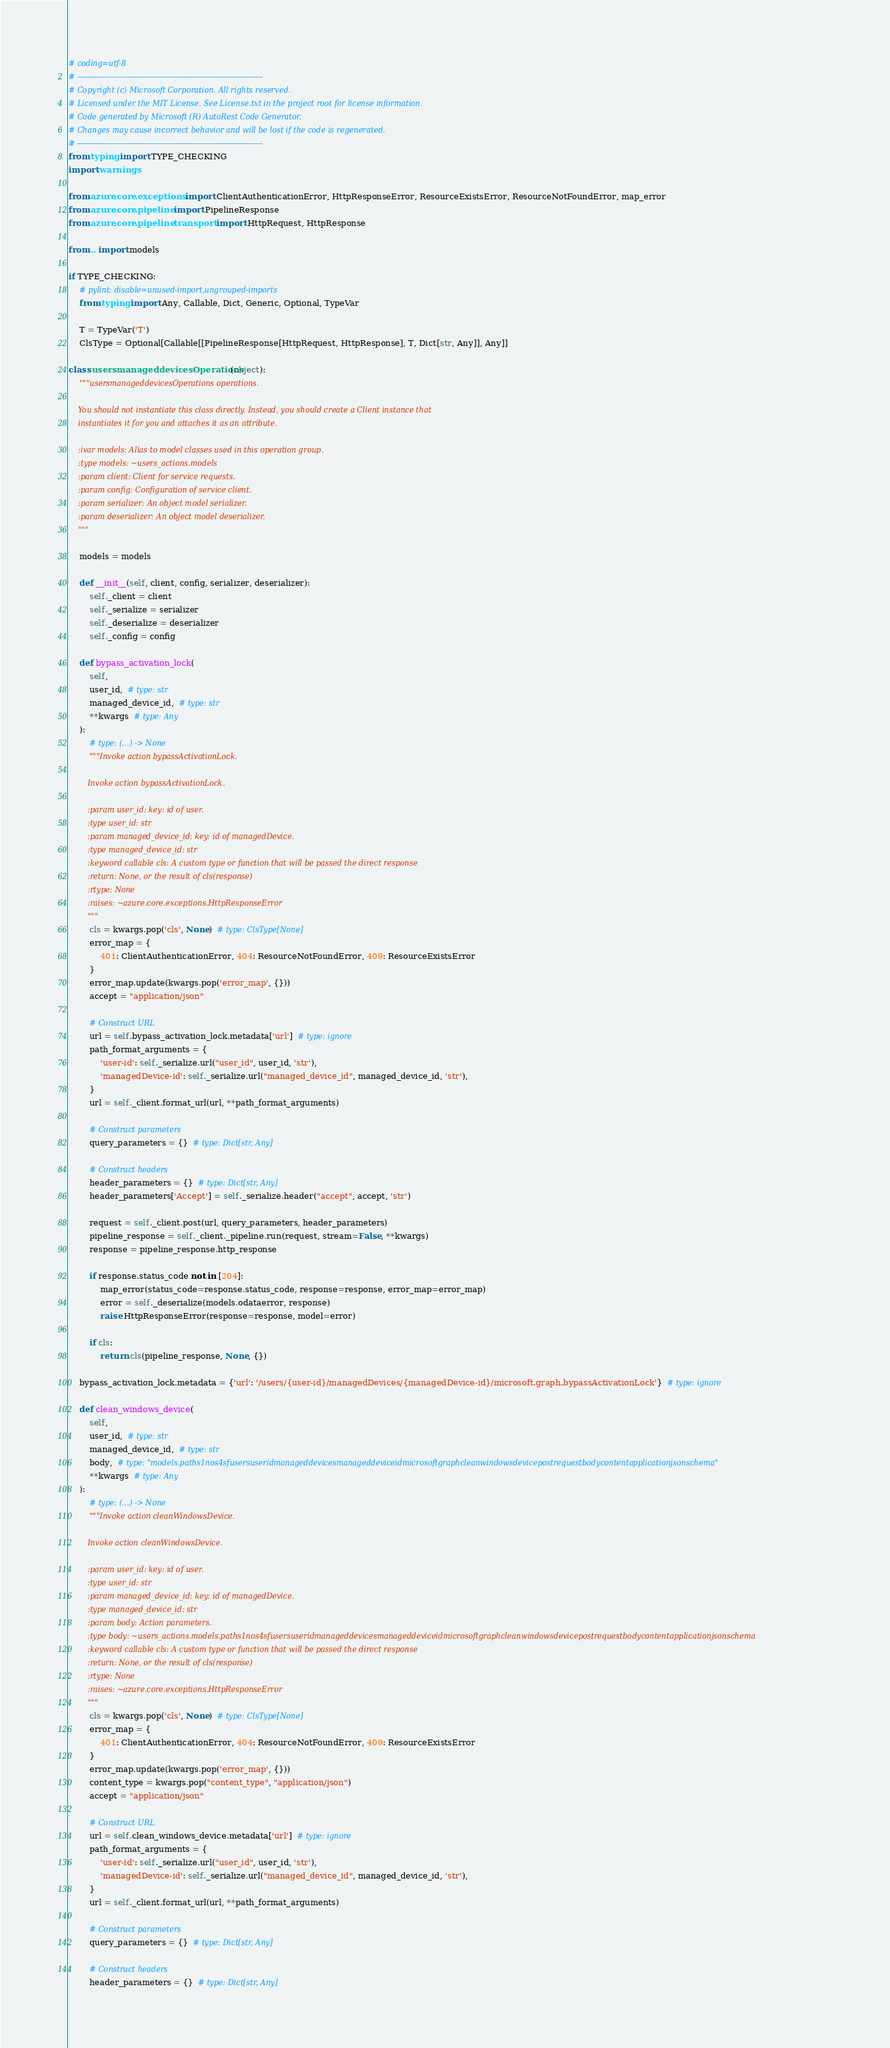Convert code to text. <code><loc_0><loc_0><loc_500><loc_500><_Python_># coding=utf-8
# --------------------------------------------------------------------------
# Copyright (c) Microsoft Corporation. All rights reserved.
# Licensed under the MIT License. See License.txt in the project root for license information.
# Code generated by Microsoft (R) AutoRest Code Generator.
# Changes may cause incorrect behavior and will be lost if the code is regenerated.
# --------------------------------------------------------------------------
from typing import TYPE_CHECKING
import warnings

from azure.core.exceptions import ClientAuthenticationError, HttpResponseError, ResourceExistsError, ResourceNotFoundError, map_error
from azure.core.pipeline import PipelineResponse
from azure.core.pipeline.transport import HttpRequest, HttpResponse

from .. import models

if TYPE_CHECKING:
    # pylint: disable=unused-import,ungrouped-imports
    from typing import Any, Callable, Dict, Generic, Optional, TypeVar

    T = TypeVar('T')
    ClsType = Optional[Callable[[PipelineResponse[HttpRequest, HttpResponse], T, Dict[str, Any]], Any]]

class usersmanageddevicesOperations(object):
    """usersmanageddevicesOperations operations.

    You should not instantiate this class directly. Instead, you should create a Client instance that
    instantiates it for you and attaches it as an attribute.

    :ivar models: Alias to model classes used in this operation group.
    :type models: ~users_actions.models
    :param client: Client for service requests.
    :param config: Configuration of service client.
    :param serializer: An object model serializer.
    :param deserializer: An object model deserializer.
    """

    models = models

    def __init__(self, client, config, serializer, deserializer):
        self._client = client
        self._serialize = serializer
        self._deserialize = deserializer
        self._config = config

    def bypass_activation_lock(
        self,
        user_id,  # type: str
        managed_device_id,  # type: str
        **kwargs  # type: Any
    ):
        # type: (...) -> None
        """Invoke action bypassActivationLock.

        Invoke action bypassActivationLock.

        :param user_id: key: id of user.
        :type user_id: str
        :param managed_device_id: key: id of managedDevice.
        :type managed_device_id: str
        :keyword callable cls: A custom type or function that will be passed the direct response
        :return: None, or the result of cls(response)
        :rtype: None
        :raises: ~azure.core.exceptions.HttpResponseError
        """
        cls = kwargs.pop('cls', None)  # type: ClsType[None]
        error_map = {
            401: ClientAuthenticationError, 404: ResourceNotFoundError, 409: ResourceExistsError
        }
        error_map.update(kwargs.pop('error_map', {}))
        accept = "application/json"

        # Construct URL
        url = self.bypass_activation_lock.metadata['url']  # type: ignore
        path_format_arguments = {
            'user-id': self._serialize.url("user_id", user_id, 'str'),
            'managedDevice-id': self._serialize.url("managed_device_id", managed_device_id, 'str'),
        }
        url = self._client.format_url(url, **path_format_arguments)

        # Construct parameters
        query_parameters = {}  # type: Dict[str, Any]

        # Construct headers
        header_parameters = {}  # type: Dict[str, Any]
        header_parameters['Accept'] = self._serialize.header("accept", accept, 'str')

        request = self._client.post(url, query_parameters, header_parameters)
        pipeline_response = self._client._pipeline.run(request, stream=False, **kwargs)
        response = pipeline_response.http_response

        if response.status_code not in [204]:
            map_error(status_code=response.status_code, response=response, error_map=error_map)
            error = self._deserialize(models.odataerror, response)
            raise HttpResponseError(response=response, model=error)

        if cls:
            return cls(pipeline_response, None, {})

    bypass_activation_lock.metadata = {'url': '/users/{user-id}/managedDevices/{managedDevice-id}/microsoft.graph.bypassActivationLock'}  # type: ignore

    def clean_windows_device(
        self,
        user_id,  # type: str
        managed_device_id,  # type: str
        body,  # type: "models.paths1nos4sfusersuseridmanageddevicesmanageddeviceidmicrosoftgraphcleanwindowsdevicepostrequestbodycontentapplicationjsonschema"
        **kwargs  # type: Any
    ):
        # type: (...) -> None
        """Invoke action cleanWindowsDevice.

        Invoke action cleanWindowsDevice.

        :param user_id: key: id of user.
        :type user_id: str
        :param managed_device_id: key: id of managedDevice.
        :type managed_device_id: str
        :param body: Action parameters.
        :type body: ~users_actions.models.paths1nos4sfusersuseridmanageddevicesmanageddeviceidmicrosoftgraphcleanwindowsdevicepostrequestbodycontentapplicationjsonschema
        :keyword callable cls: A custom type or function that will be passed the direct response
        :return: None, or the result of cls(response)
        :rtype: None
        :raises: ~azure.core.exceptions.HttpResponseError
        """
        cls = kwargs.pop('cls', None)  # type: ClsType[None]
        error_map = {
            401: ClientAuthenticationError, 404: ResourceNotFoundError, 409: ResourceExistsError
        }
        error_map.update(kwargs.pop('error_map', {}))
        content_type = kwargs.pop("content_type", "application/json")
        accept = "application/json"

        # Construct URL
        url = self.clean_windows_device.metadata['url']  # type: ignore
        path_format_arguments = {
            'user-id': self._serialize.url("user_id", user_id, 'str'),
            'managedDevice-id': self._serialize.url("managed_device_id", managed_device_id, 'str'),
        }
        url = self._client.format_url(url, **path_format_arguments)

        # Construct parameters
        query_parameters = {}  # type: Dict[str, Any]

        # Construct headers
        header_parameters = {}  # type: Dict[str, Any]</code> 